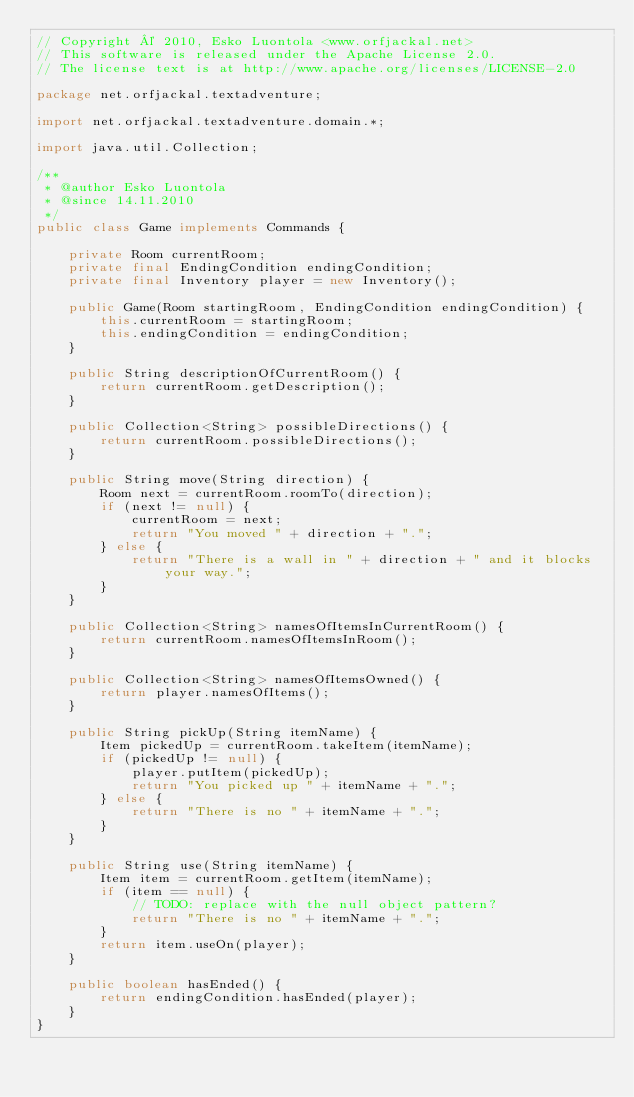Convert code to text. <code><loc_0><loc_0><loc_500><loc_500><_Java_>// Copyright © 2010, Esko Luontola <www.orfjackal.net>
// This software is released under the Apache License 2.0.
// The license text is at http://www.apache.org/licenses/LICENSE-2.0

package net.orfjackal.textadventure;

import net.orfjackal.textadventure.domain.*;

import java.util.Collection;

/**
 * @author Esko Luontola
 * @since 14.11.2010
 */
public class Game implements Commands {

    private Room currentRoom;
    private final EndingCondition endingCondition;
    private final Inventory player = new Inventory();

    public Game(Room startingRoom, EndingCondition endingCondition) {
        this.currentRoom = startingRoom;
        this.endingCondition = endingCondition;
    }

    public String descriptionOfCurrentRoom() {
        return currentRoom.getDescription();
    }

    public Collection<String> possibleDirections() {
        return currentRoom.possibleDirections();
    }

    public String move(String direction) {
        Room next = currentRoom.roomTo(direction);
        if (next != null) {
            currentRoom = next;
            return "You moved " + direction + ".";
        } else {
            return "There is a wall in " + direction + " and it blocks your way.";
        }
    }

    public Collection<String> namesOfItemsInCurrentRoom() {
        return currentRoom.namesOfItemsInRoom();
    }

    public Collection<String> namesOfItemsOwned() {
        return player.namesOfItems();
    }

    public String pickUp(String itemName) {
        Item pickedUp = currentRoom.takeItem(itemName);
        if (pickedUp != null) {
            player.putItem(pickedUp);
            return "You picked up " + itemName + ".";
        } else {
            return "There is no " + itemName + ".";
        }
    }

    public String use(String itemName) {
        Item item = currentRoom.getItem(itemName);
        if (item == null) {
            // TODO: replace with the null object pattern?
            return "There is no " + itemName + ".";
        }
        return item.useOn(player);
    }

    public boolean hasEnded() {
        return endingCondition.hasEnded(player);
    }
}
</code> 